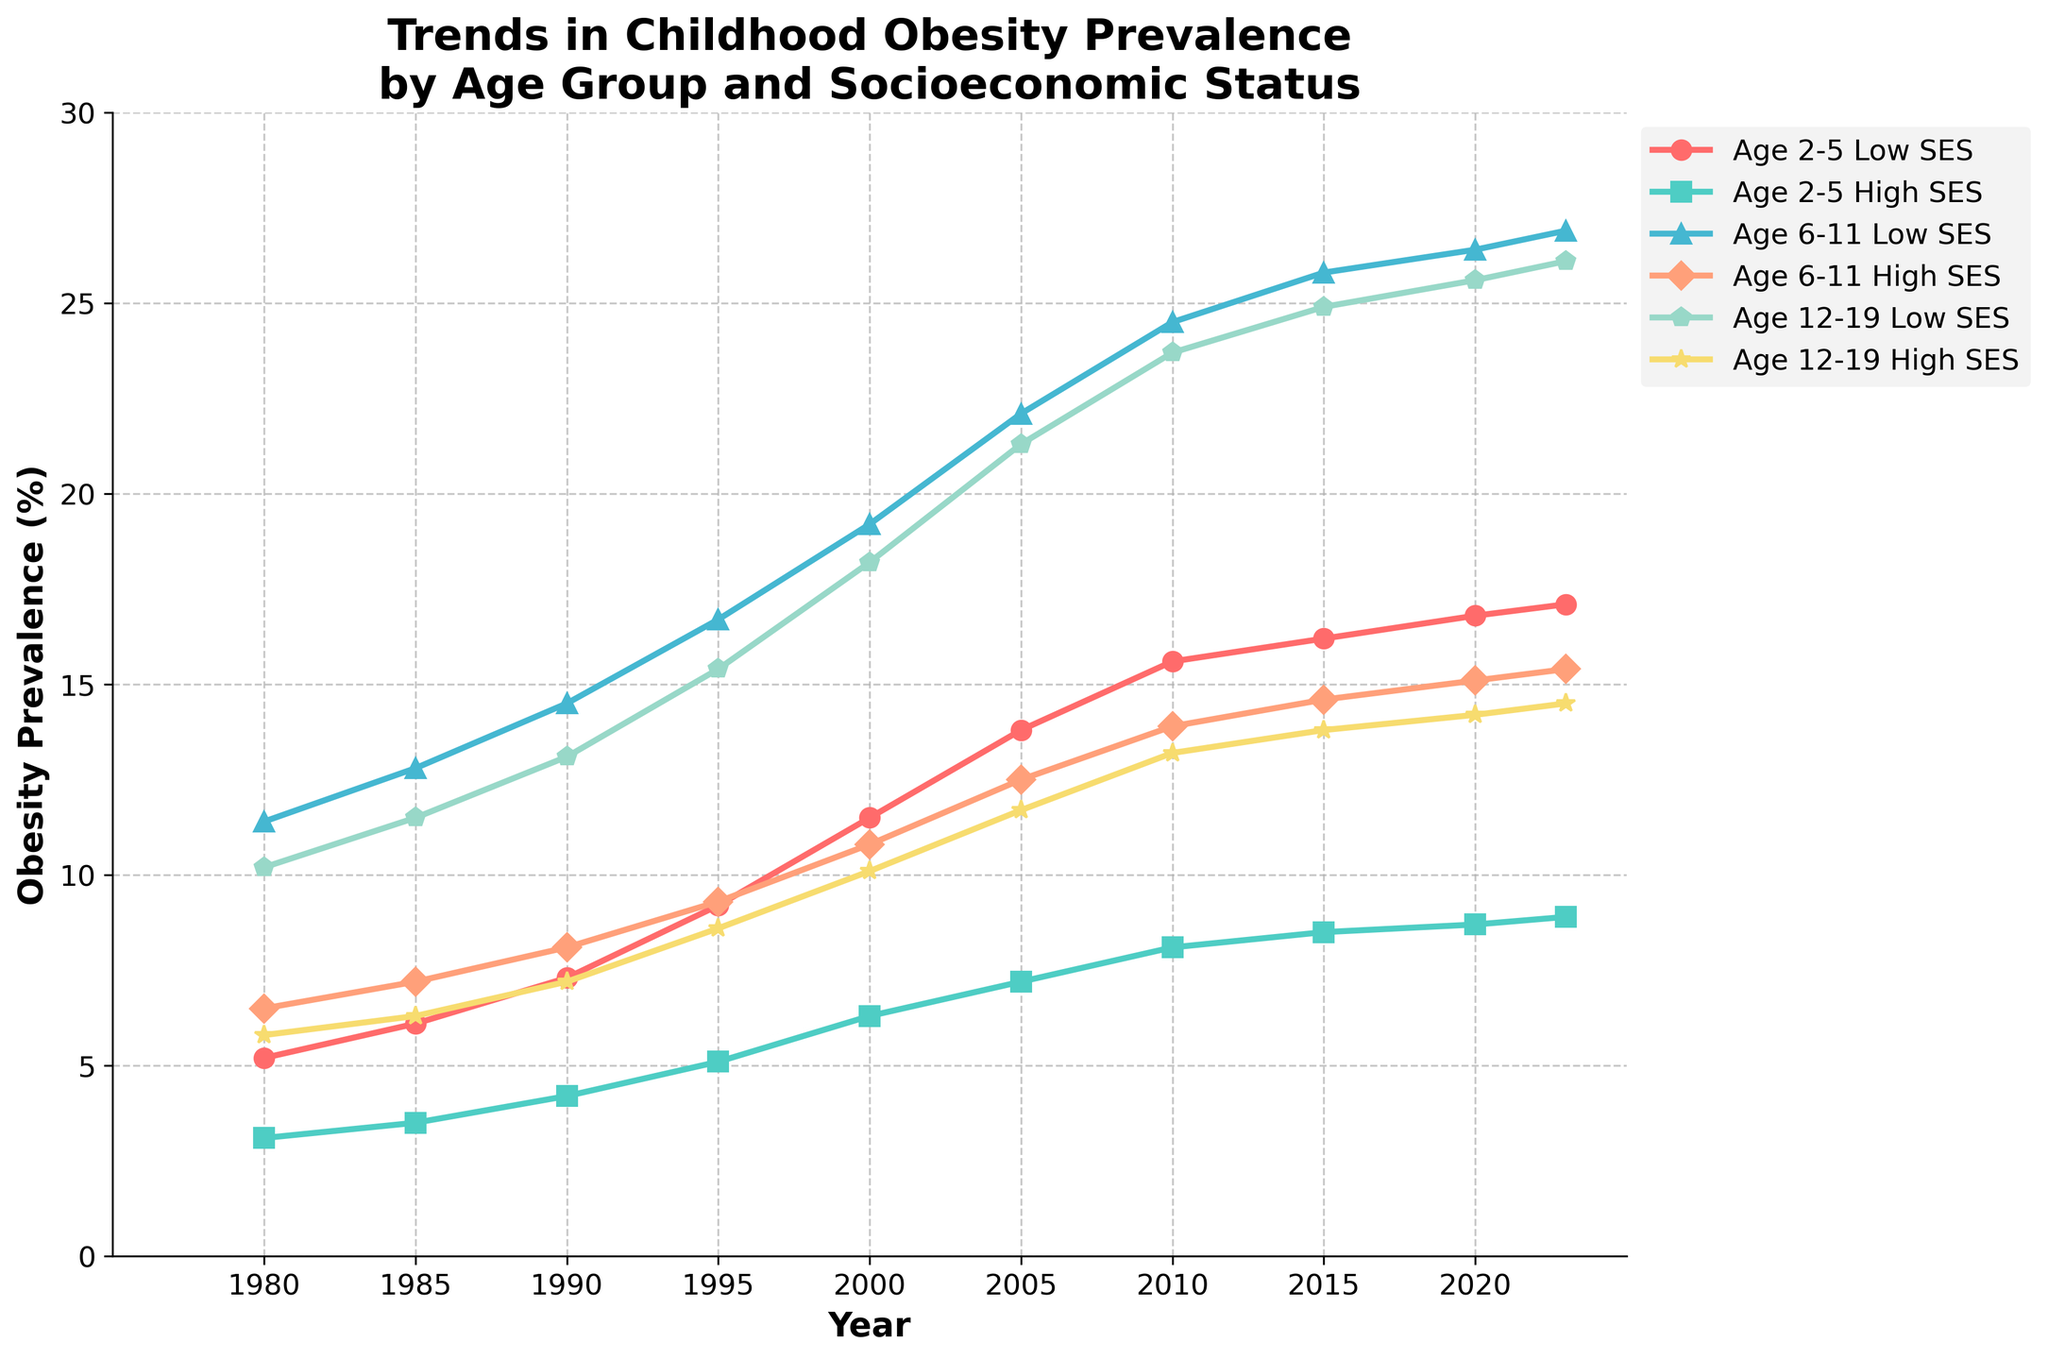What is the trend in obesity prevalence among children aged 2-5 from low socioeconomic status (SES) over the years? The red line with circle markers represents children aged 2-5 from low SES. Observing the chart, the prevalence starts at 5.2% in 1980 and shows a continuous increase over the years, reaching 17.1% in 2023.
Answer: Continuous increase How does the obesity prevalence in 2023 for children aged 6-11 from high SES compare to that of children aged 6-11 from low SES? By looking at the endpoint of the lines for 2023, children aged 6-11 from high SES have an obesity prevalence of 15.4%, while those from low SES have a higher prevalence of 26.9%.
Answer: Higher in low SES Which age group shows the highest increase in obesity prevalence from 1980 to 2023 for high SES? Comparing the starting and ending points for all high SES groups: Age 2-5 starts at 3.1% and ends at 8.9% (5.8% increase), Age 6-11 starts at 6.5% and ends at 15.4% (8.9% increase), and Age 12-19 starts at 5.8% and ends at 14.5% (8.7% increase). Therefore, Age 6-11 shows the highest increase.
Answer: Age 6-11 What was the obesity prevalence among children aged 12-19 from low SES in the year 2000? Locate the blue line with diamond markers and find the data point for the year 2000, which corresponds to 18.2%.
Answer: 18.2% Which group has the smallest obesity prevalence in 1980, and what is the value? Comparing the endpoints for 1980 reveals that the group Age 2-5 High SES (represented by turquoise square markers) had the lowest prevalence at 3.1%.
Answer: Age 2-5 High SES, 3.1% By how much did obesity prevalence increase among children aged 12-19 from low SES between 1990 and 2020? Subtract the 1990 value (13.1%) from the 2020 value (25.6%) for the low SES Age 12-19 group as shown by the blue diamond markers: 25.6% - 13.1% = 12.5%.
Answer: 12.5% Compare the rate of increase in obesity prevalence from 1980 to 2000 between children aged 2-5 from low SES and high SES. From 1980 to 2000, the low SES group (red with circles) starts at 5.2% and reaches 11.5%, an increase of 6.3%. The high SES group (turquoise with squares) starts at 3.1% and reaches 6.3%, an increase of 3.2%. Thus, the increase rate is higher in the low SES group.
Answer: Higher among low SES What is the average obesity prevalence for children aged 6-11 from high SES across all available years? Add the values for years 1980, 1985, 1990, 1995, 2000, 2005, 2010, 2015, 2020, and 2023 for Age 6-11 High SES (6.5%, 7.2%, 8.1%, 9.3%, 10.8%, 12.5%, 13.9%, 14.6%, 15.1%, 15.4%), then divide by 10: (6.5 + 7.2 + 8.1 + 9.3 + 10.8 + 12.5 + 13.9 + 14.6 + 15.1 + 15.4) / 10 = 11.34%.
Answer: 11.34% 